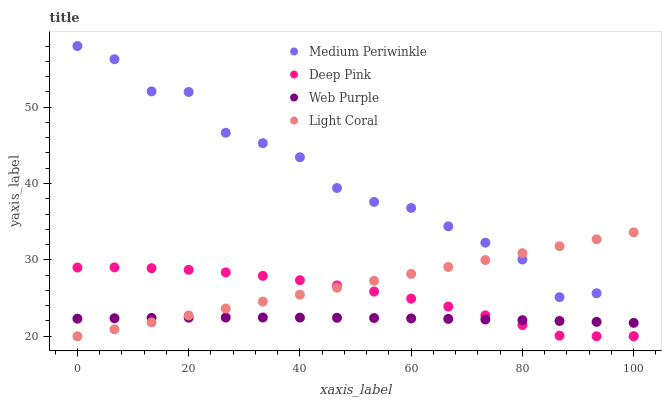Does Web Purple have the minimum area under the curve?
Answer yes or no. Yes. Does Medium Periwinkle have the maximum area under the curve?
Answer yes or no. Yes. Does Deep Pink have the minimum area under the curve?
Answer yes or no. No. Does Deep Pink have the maximum area under the curve?
Answer yes or no. No. Is Light Coral the smoothest?
Answer yes or no. Yes. Is Medium Periwinkle the roughest?
Answer yes or no. Yes. Is Web Purple the smoothest?
Answer yes or no. No. Is Web Purple the roughest?
Answer yes or no. No. Does Light Coral have the lowest value?
Answer yes or no. Yes. Does Web Purple have the lowest value?
Answer yes or no. No. Does Medium Periwinkle have the highest value?
Answer yes or no. Yes. Does Deep Pink have the highest value?
Answer yes or no. No. Does Medium Periwinkle intersect Light Coral?
Answer yes or no. Yes. Is Medium Periwinkle less than Light Coral?
Answer yes or no. No. Is Medium Periwinkle greater than Light Coral?
Answer yes or no. No. 